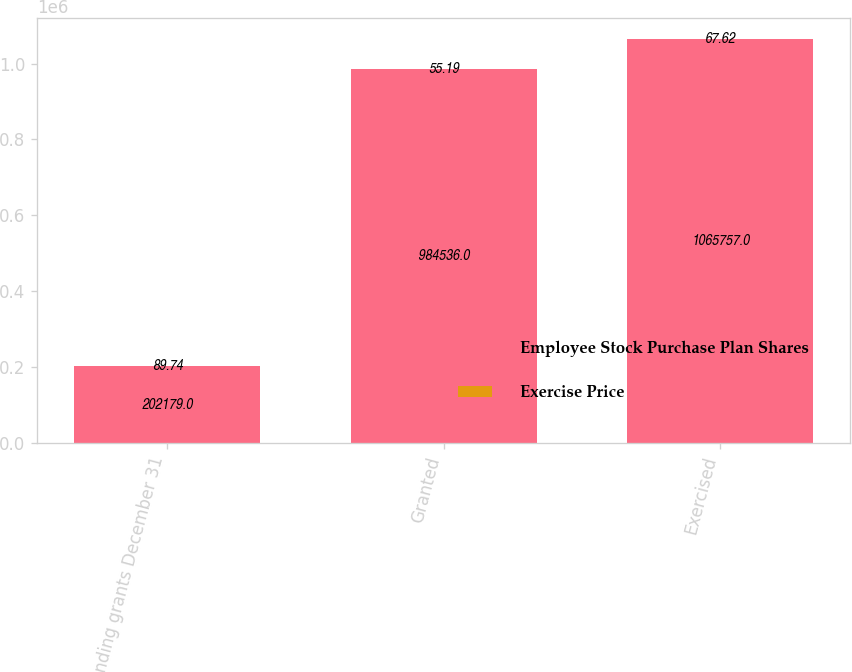Convert chart to OTSL. <chart><loc_0><loc_0><loc_500><loc_500><stacked_bar_chart><ecel><fcel>Outstanding grants December 31<fcel>Granted<fcel>Exercised<nl><fcel>Employee Stock Purchase Plan Shares<fcel>202179<fcel>984536<fcel>1.06576e+06<nl><fcel>Exercise Price<fcel>89.74<fcel>55.19<fcel>67.62<nl></chart> 